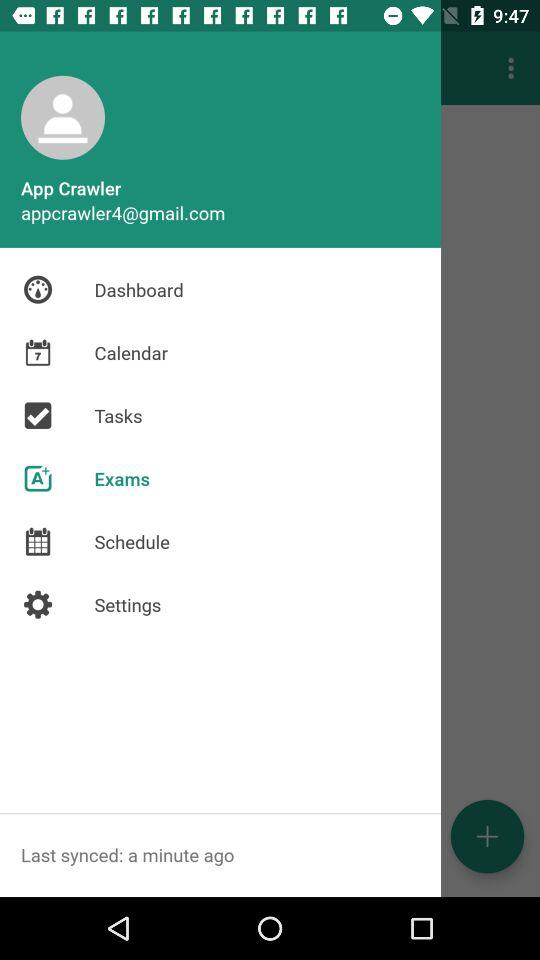What is the user email address? The user email address is appcrawler4@gmail.com. 